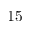Convert formula to latex. <formula><loc_0><loc_0><loc_500><loc_500>1 5</formula> 